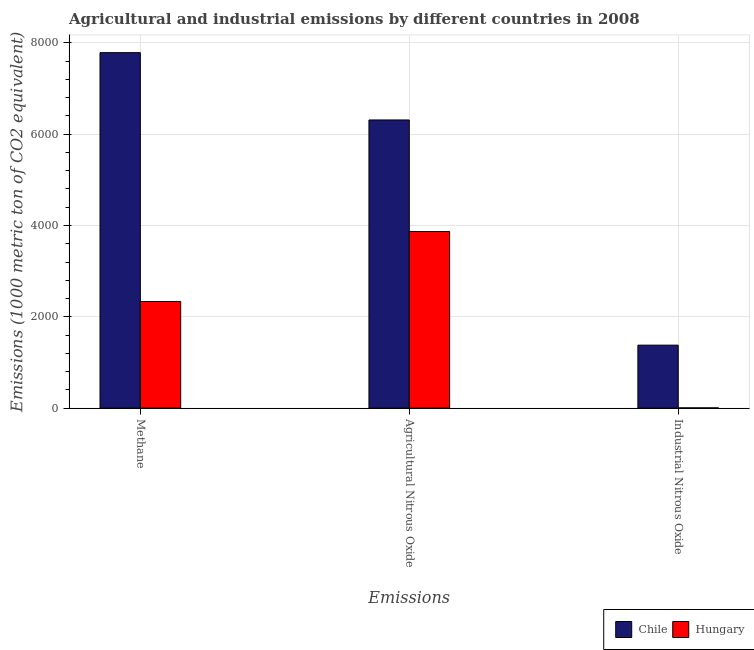How many groups of bars are there?
Ensure brevity in your answer.  3. How many bars are there on the 1st tick from the left?
Your answer should be compact. 2. What is the label of the 1st group of bars from the left?
Give a very brief answer. Methane. What is the amount of methane emissions in Hungary?
Give a very brief answer. 2335.2. Across all countries, what is the maximum amount of agricultural nitrous oxide emissions?
Provide a succinct answer. 6312. Across all countries, what is the minimum amount of methane emissions?
Make the answer very short. 2335.2. In which country was the amount of agricultural nitrous oxide emissions maximum?
Keep it short and to the point. Chile. In which country was the amount of agricultural nitrous oxide emissions minimum?
Offer a very short reply. Hungary. What is the total amount of agricultural nitrous oxide emissions in the graph?
Your answer should be compact. 1.02e+04. What is the difference between the amount of agricultural nitrous oxide emissions in Chile and that in Hungary?
Give a very brief answer. 2444. What is the difference between the amount of industrial nitrous oxide emissions in Chile and the amount of methane emissions in Hungary?
Make the answer very short. -955.5. What is the average amount of methane emissions per country?
Offer a terse response. 5060.65. What is the difference between the amount of agricultural nitrous oxide emissions and amount of industrial nitrous oxide emissions in Chile?
Your answer should be compact. 4932.3. In how many countries, is the amount of industrial nitrous oxide emissions greater than 3600 metric ton?
Offer a very short reply. 0. What is the ratio of the amount of industrial nitrous oxide emissions in Chile to that in Hungary?
Provide a succinct answer. 229.95. What is the difference between the highest and the second highest amount of industrial nitrous oxide emissions?
Provide a short and direct response. 1373.7. What is the difference between the highest and the lowest amount of industrial nitrous oxide emissions?
Your answer should be very brief. 1373.7. Is the sum of the amount of industrial nitrous oxide emissions in Hungary and Chile greater than the maximum amount of agricultural nitrous oxide emissions across all countries?
Make the answer very short. No. What does the 2nd bar from the left in Agricultural Nitrous Oxide represents?
Provide a succinct answer. Hungary. What does the 1st bar from the right in Methane represents?
Ensure brevity in your answer.  Hungary. How many bars are there?
Provide a succinct answer. 6. What is the difference between two consecutive major ticks on the Y-axis?
Ensure brevity in your answer.  2000. Are the values on the major ticks of Y-axis written in scientific E-notation?
Offer a terse response. No. Does the graph contain any zero values?
Offer a very short reply. No. Does the graph contain grids?
Offer a terse response. Yes. What is the title of the graph?
Make the answer very short. Agricultural and industrial emissions by different countries in 2008. Does "Equatorial Guinea" appear as one of the legend labels in the graph?
Make the answer very short. No. What is the label or title of the X-axis?
Keep it short and to the point. Emissions. What is the label or title of the Y-axis?
Provide a succinct answer. Emissions (1000 metric ton of CO2 equivalent). What is the Emissions (1000 metric ton of CO2 equivalent) of Chile in Methane?
Offer a terse response. 7786.1. What is the Emissions (1000 metric ton of CO2 equivalent) of Hungary in Methane?
Your answer should be compact. 2335.2. What is the Emissions (1000 metric ton of CO2 equivalent) in Chile in Agricultural Nitrous Oxide?
Make the answer very short. 6312. What is the Emissions (1000 metric ton of CO2 equivalent) of Hungary in Agricultural Nitrous Oxide?
Your answer should be very brief. 3868. What is the Emissions (1000 metric ton of CO2 equivalent) of Chile in Industrial Nitrous Oxide?
Give a very brief answer. 1379.7. Across all Emissions, what is the maximum Emissions (1000 metric ton of CO2 equivalent) in Chile?
Provide a short and direct response. 7786.1. Across all Emissions, what is the maximum Emissions (1000 metric ton of CO2 equivalent) of Hungary?
Provide a succinct answer. 3868. Across all Emissions, what is the minimum Emissions (1000 metric ton of CO2 equivalent) in Chile?
Ensure brevity in your answer.  1379.7. Across all Emissions, what is the minimum Emissions (1000 metric ton of CO2 equivalent) of Hungary?
Your response must be concise. 6. What is the total Emissions (1000 metric ton of CO2 equivalent) of Chile in the graph?
Your answer should be very brief. 1.55e+04. What is the total Emissions (1000 metric ton of CO2 equivalent) in Hungary in the graph?
Keep it short and to the point. 6209.2. What is the difference between the Emissions (1000 metric ton of CO2 equivalent) of Chile in Methane and that in Agricultural Nitrous Oxide?
Offer a terse response. 1474.1. What is the difference between the Emissions (1000 metric ton of CO2 equivalent) of Hungary in Methane and that in Agricultural Nitrous Oxide?
Keep it short and to the point. -1532.8. What is the difference between the Emissions (1000 metric ton of CO2 equivalent) in Chile in Methane and that in Industrial Nitrous Oxide?
Ensure brevity in your answer.  6406.4. What is the difference between the Emissions (1000 metric ton of CO2 equivalent) of Hungary in Methane and that in Industrial Nitrous Oxide?
Provide a succinct answer. 2329.2. What is the difference between the Emissions (1000 metric ton of CO2 equivalent) in Chile in Agricultural Nitrous Oxide and that in Industrial Nitrous Oxide?
Keep it short and to the point. 4932.3. What is the difference between the Emissions (1000 metric ton of CO2 equivalent) of Hungary in Agricultural Nitrous Oxide and that in Industrial Nitrous Oxide?
Keep it short and to the point. 3862. What is the difference between the Emissions (1000 metric ton of CO2 equivalent) of Chile in Methane and the Emissions (1000 metric ton of CO2 equivalent) of Hungary in Agricultural Nitrous Oxide?
Your answer should be compact. 3918.1. What is the difference between the Emissions (1000 metric ton of CO2 equivalent) in Chile in Methane and the Emissions (1000 metric ton of CO2 equivalent) in Hungary in Industrial Nitrous Oxide?
Provide a succinct answer. 7780.1. What is the difference between the Emissions (1000 metric ton of CO2 equivalent) of Chile in Agricultural Nitrous Oxide and the Emissions (1000 metric ton of CO2 equivalent) of Hungary in Industrial Nitrous Oxide?
Keep it short and to the point. 6306. What is the average Emissions (1000 metric ton of CO2 equivalent) in Chile per Emissions?
Keep it short and to the point. 5159.27. What is the average Emissions (1000 metric ton of CO2 equivalent) in Hungary per Emissions?
Make the answer very short. 2069.73. What is the difference between the Emissions (1000 metric ton of CO2 equivalent) in Chile and Emissions (1000 metric ton of CO2 equivalent) in Hungary in Methane?
Offer a very short reply. 5450.9. What is the difference between the Emissions (1000 metric ton of CO2 equivalent) of Chile and Emissions (1000 metric ton of CO2 equivalent) of Hungary in Agricultural Nitrous Oxide?
Provide a short and direct response. 2444. What is the difference between the Emissions (1000 metric ton of CO2 equivalent) in Chile and Emissions (1000 metric ton of CO2 equivalent) in Hungary in Industrial Nitrous Oxide?
Make the answer very short. 1373.7. What is the ratio of the Emissions (1000 metric ton of CO2 equivalent) in Chile in Methane to that in Agricultural Nitrous Oxide?
Give a very brief answer. 1.23. What is the ratio of the Emissions (1000 metric ton of CO2 equivalent) of Hungary in Methane to that in Agricultural Nitrous Oxide?
Provide a short and direct response. 0.6. What is the ratio of the Emissions (1000 metric ton of CO2 equivalent) of Chile in Methane to that in Industrial Nitrous Oxide?
Keep it short and to the point. 5.64. What is the ratio of the Emissions (1000 metric ton of CO2 equivalent) of Hungary in Methane to that in Industrial Nitrous Oxide?
Your response must be concise. 389.2. What is the ratio of the Emissions (1000 metric ton of CO2 equivalent) of Chile in Agricultural Nitrous Oxide to that in Industrial Nitrous Oxide?
Offer a very short reply. 4.57. What is the ratio of the Emissions (1000 metric ton of CO2 equivalent) of Hungary in Agricultural Nitrous Oxide to that in Industrial Nitrous Oxide?
Your answer should be very brief. 644.67. What is the difference between the highest and the second highest Emissions (1000 metric ton of CO2 equivalent) of Chile?
Offer a very short reply. 1474.1. What is the difference between the highest and the second highest Emissions (1000 metric ton of CO2 equivalent) of Hungary?
Your answer should be very brief. 1532.8. What is the difference between the highest and the lowest Emissions (1000 metric ton of CO2 equivalent) in Chile?
Provide a short and direct response. 6406.4. What is the difference between the highest and the lowest Emissions (1000 metric ton of CO2 equivalent) in Hungary?
Keep it short and to the point. 3862. 